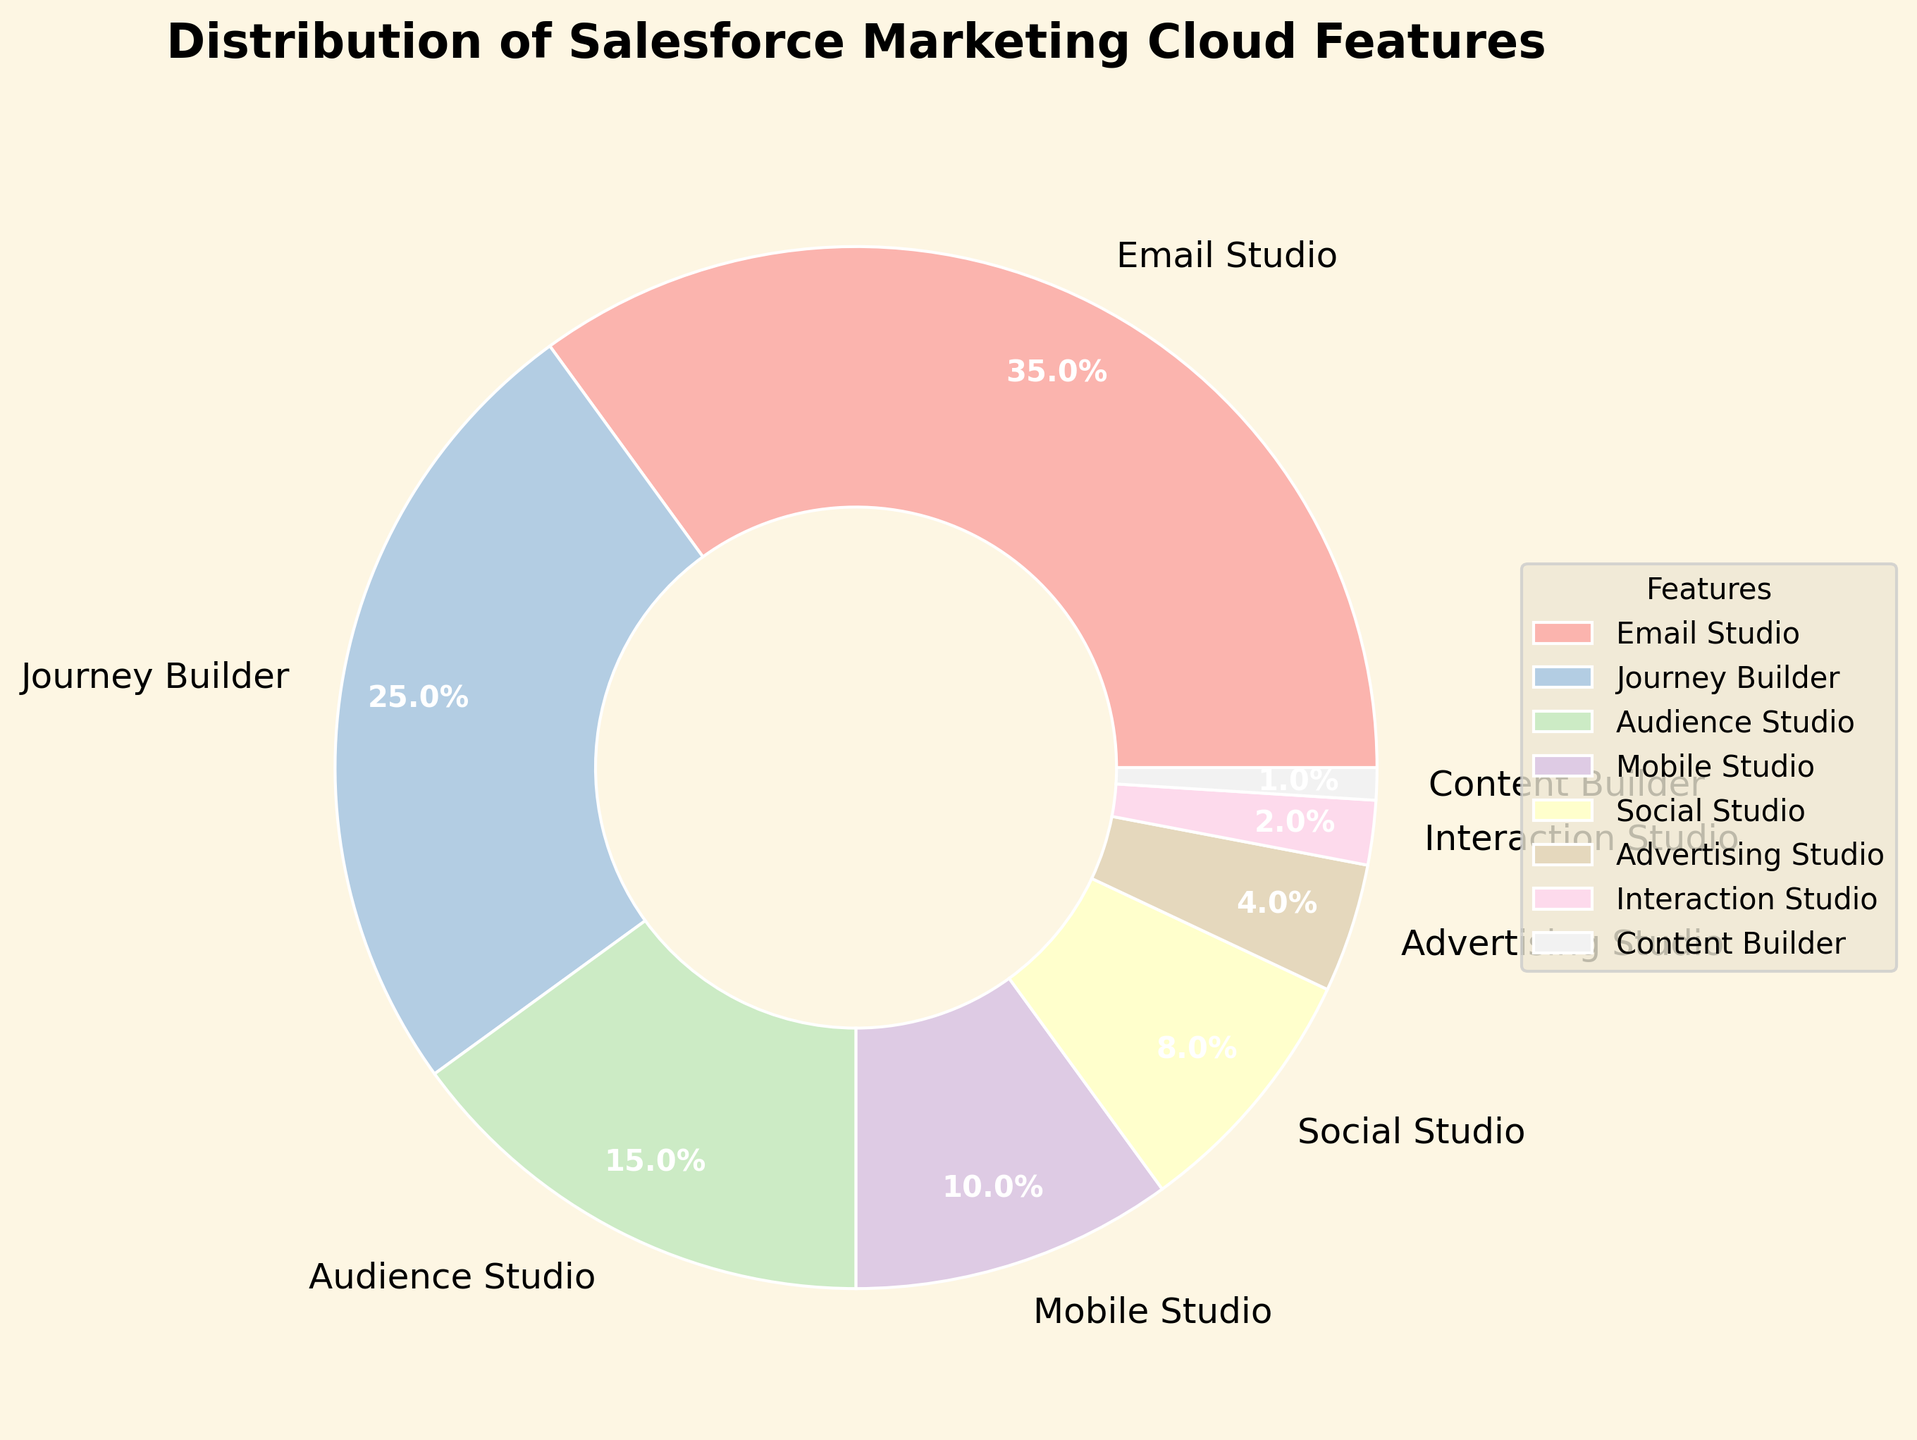What is the feature with the highest percentage? The feature with the highest percentage can be determined by looking for the largest slice in the pie chart and reading the corresponding label.
Answer: Email Studio How much larger is the percentage of Email Studio compared to Journey Builder? Subtract the percentage of Journey Builder from the percentage of Email Studio (35% - 25%).
Answer: 10% What is the combined percentage of Audience Studio, Mobile Studio, and Social Studio? Add the percentages of Audience Studio (15%), Mobile Studio (10%), and Social Studio (8%) together (15% + 10% + 8%).
Answer: 33% Which feature has the smallest percentage, and what is it? Identify the smallest slice in the pie chart and read the corresponding label and value.
Answer: Content Builder, 1% Are there more clients using Journey Builder than those using Audience Studio and Interaction Studio combined? Add the percentages of Audience Studio (15%) and Interaction Studio (2%) together (15% + 2%) and compare with the percentage of Journey Builder (25%). 25% is greater than 17%.
Answer: Yes What is the difference in percentage between the least used and the most used feature? Subtract the percentage of the least used feature (Content Builder, 1%) from the most used feature (Email Studio, 35%) (35% - 1%).
Answer: 34% Which two features have the closest percentage usage? Compare and find the smallest difference between any two percentages, which are Advertising Studio (4%) and Interaction Studio (2%), with a difference of 2%.
Answer: Advertising Studio and Interaction Studio What percentage of clients use both Email Studio and Journey Builder together? Add the percentages of Email Studio (35%) and Journey Builder (25%) (35% + 25%).
Answer: 60% How does the percentage of Mobile Studio compare with Social Studio? Check the values for Mobile Studio (10%) and Social Studio (8%) and determine that Mobile Studio has a higher percentage.
Answer: Mobile Studio is higher than Social Studio 